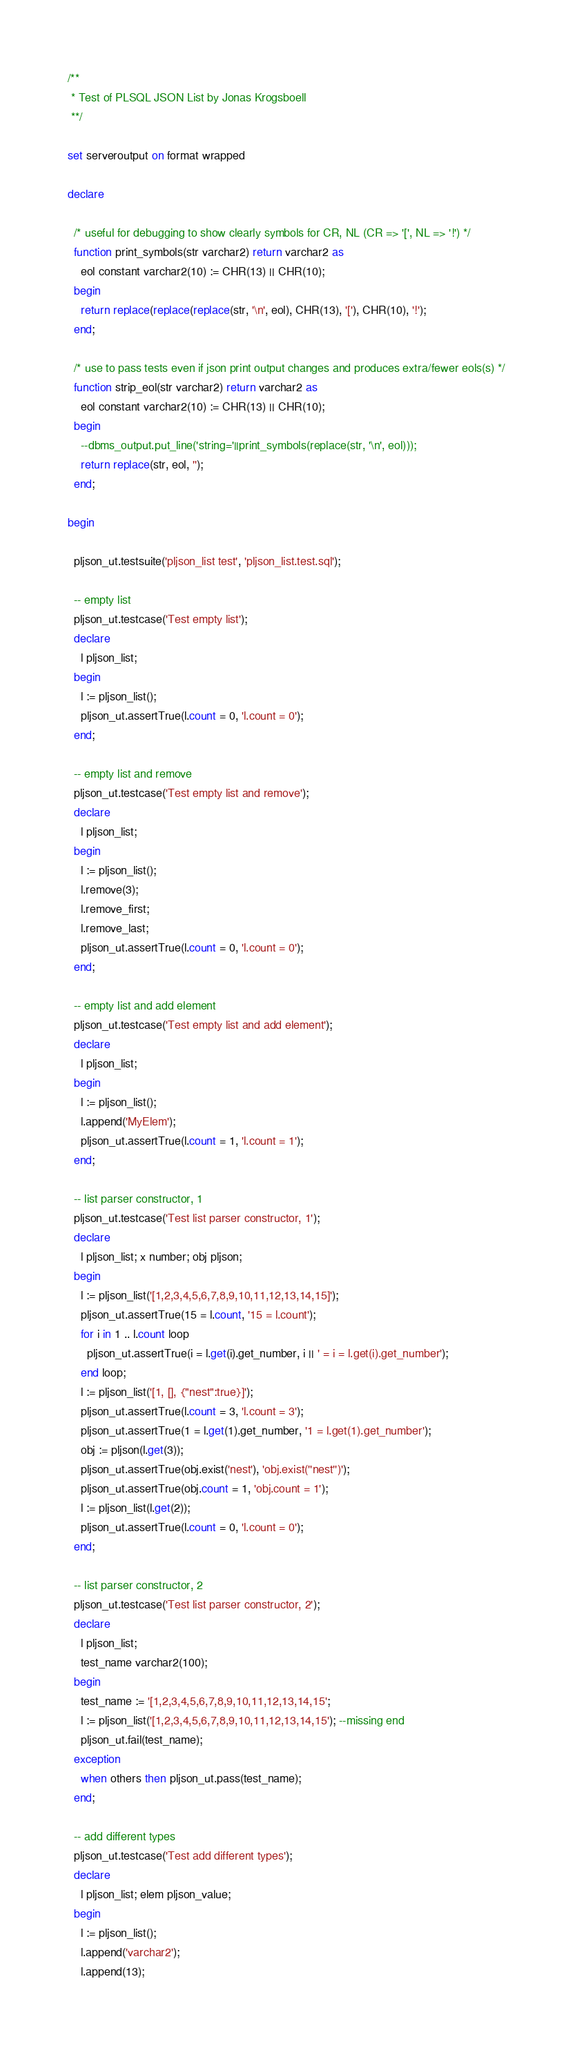<code> <loc_0><loc_0><loc_500><loc_500><_SQL_>
/**
 * Test of PLSQL JSON List by Jonas Krogsboell
 **/

set serveroutput on format wrapped

declare
  
  /* useful for debugging to show clearly symbols for CR, NL (CR => '[', NL => '!') */
  function print_symbols(str varchar2) return varchar2 as
    eol constant varchar2(10) := CHR(13) || CHR(10);
  begin
    return replace(replace(replace(str, '\n', eol), CHR(13), '['), CHR(10), '!');
  end;
  
  /* use to pass tests even if json print output changes and produces extra/fewer eols(s) */
  function strip_eol(str varchar2) return varchar2 as
    eol constant varchar2(10) := CHR(13) || CHR(10);
  begin
    --dbms_output.put_line('string='||print_symbols(replace(str, '\n', eol)));
    return replace(str, eol, '');
  end;
  
begin
  
  pljson_ut.testsuite('pljson_list test', 'pljson_list.test.sql');
  
  -- empty list
  pljson_ut.testcase('Test empty list');
  declare
    l pljson_list;
  begin
    l := pljson_list();
    pljson_ut.assertTrue(l.count = 0, 'l.count = 0');
  end;
  
  -- empty list and remove
  pljson_ut.testcase('Test empty list and remove');
  declare
    l pljson_list;
  begin
    l := pljson_list();
    l.remove(3);
    l.remove_first;
    l.remove_last;
    pljson_ut.assertTrue(l.count = 0, 'l.count = 0');
  end;
  
  -- empty list and add element
  pljson_ut.testcase('Test empty list and add element');
  declare
    l pljson_list;
  begin
    l := pljson_list();
    l.append('MyElem');
    pljson_ut.assertTrue(l.count = 1, 'l.count = 1');
  end;
  
  -- list parser constructor, 1
  pljson_ut.testcase('Test list parser constructor, 1');
  declare
    l pljson_list; x number; obj pljson;
  begin
    l := pljson_list('[1,2,3,4,5,6,7,8,9,10,11,12,13,14,15]');
    pljson_ut.assertTrue(15 = l.count, '15 = l.count');
    for i in 1 .. l.count loop
      pljson_ut.assertTrue(i = l.get(i).get_number, i || ' = i = l.get(i).get_number');
    end loop;
    l := pljson_list('[1, [], {"nest":true}]');
    pljson_ut.assertTrue(l.count = 3, 'l.count = 3');
    pljson_ut.assertTrue(1 = l.get(1).get_number, '1 = l.get(1).get_number');
    obj := pljson(l.get(3));
    pljson_ut.assertTrue(obj.exist('nest'), 'obj.exist(''nest'')');
    pljson_ut.assertTrue(obj.count = 1, 'obj.count = 1');
    l := pljson_list(l.get(2));
    pljson_ut.assertTrue(l.count = 0, 'l.count = 0');
  end;
  
  -- list parser constructor, 2
  pljson_ut.testcase('Test list parser constructor, 2');
  declare
    l pljson_list;
    test_name varchar2(100);
  begin
    test_name := '[1,2,3,4,5,6,7,8,9,10,11,12,13,14,15';
    l := pljson_list('[1,2,3,4,5,6,7,8,9,10,11,12,13,14,15'); --missing end
    pljson_ut.fail(test_name);
  exception
    when others then pljson_ut.pass(test_name);
  end;
  
  -- add different types
  pljson_ut.testcase('Test add different types');
  declare
    l pljson_list; elem pljson_value;
  begin
    l := pljson_list();
    l.append('varchar2');
    l.append(13);</code> 